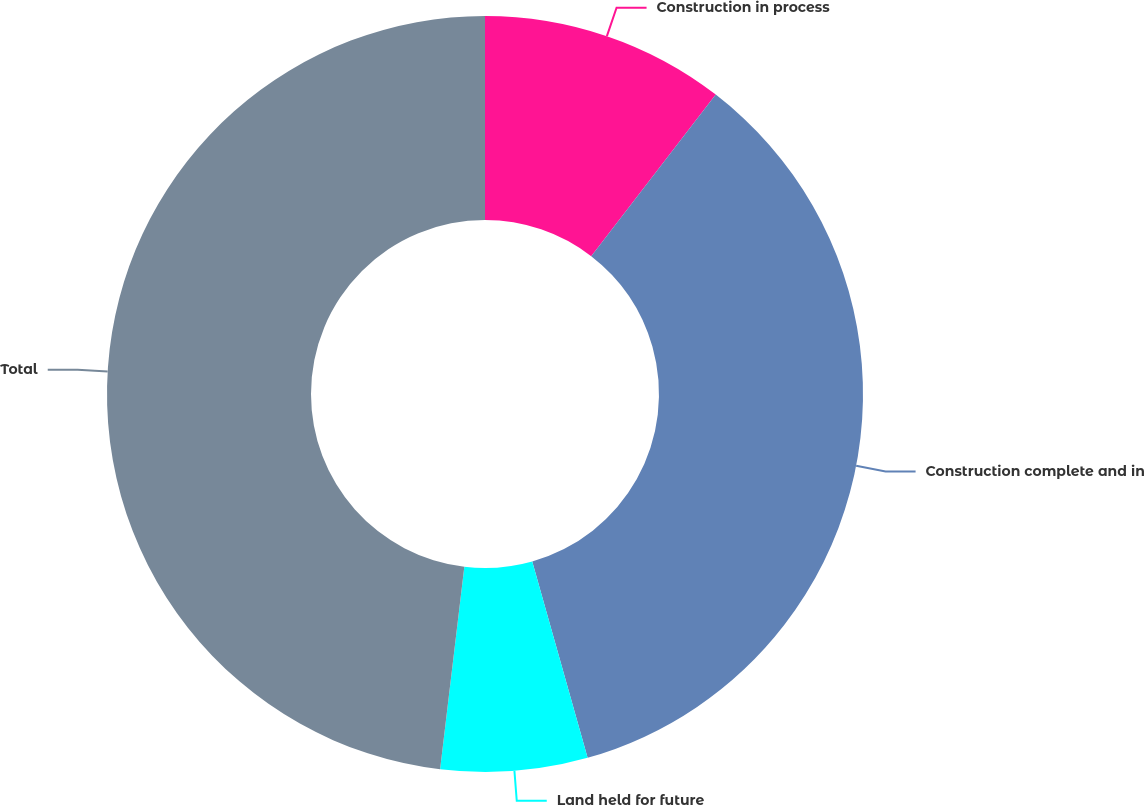<chart> <loc_0><loc_0><loc_500><loc_500><pie_chart><fcel>Construction in process<fcel>Construction complete and in<fcel>Land held for future<fcel>Total<nl><fcel>10.45%<fcel>35.17%<fcel>6.27%<fcel>48.1%<nl></chart> 